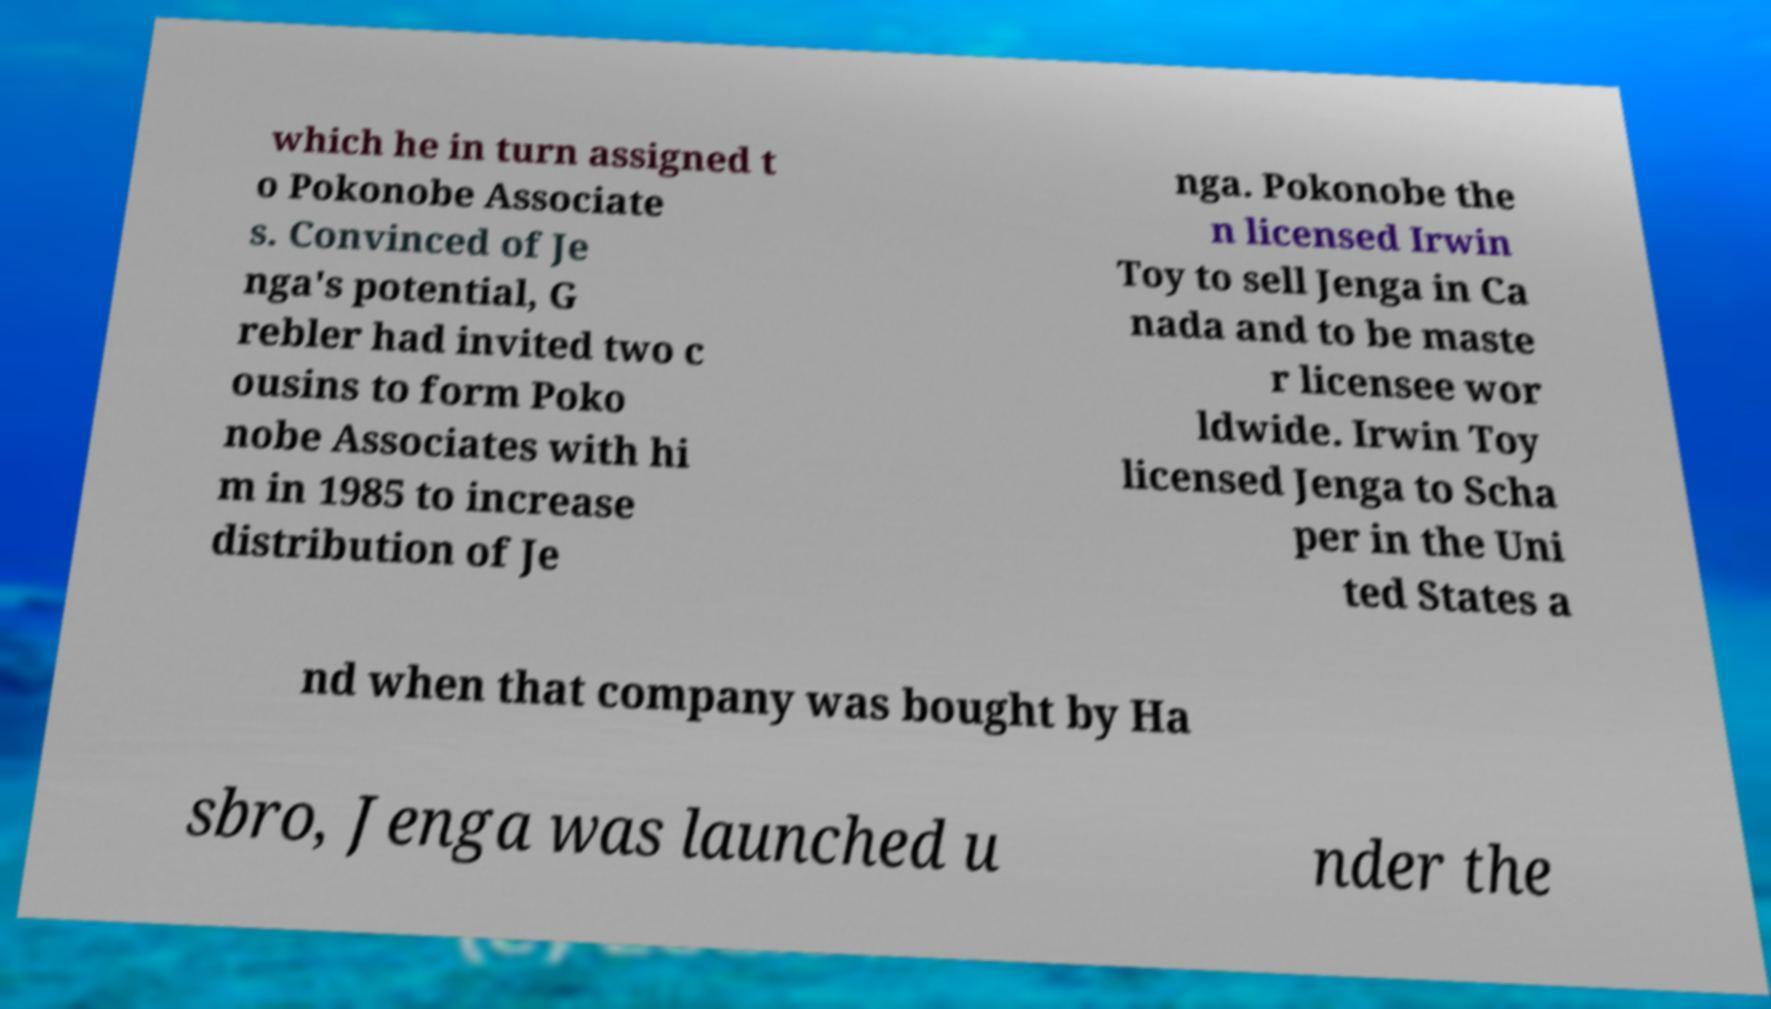What messages or text are displayed in this image? I need them in a readable, typed format. which he in turn assigned t o Pokonobe Associate s. Convinced of Je nga's potential, G rebler had invited two c ousins to form Poko nobe Associates with hi m in 1985 to increase distribution of Je nga. Pokonobe the n licensed Irwin Toy to sell Jenga in Ca nada and to be maste r licensee wor ldwide. Irwin Toy licensed Jenga to Scha per in the Uni ted States a nd when that company was bought by Ha sbro, Jenga was launched u nder the 